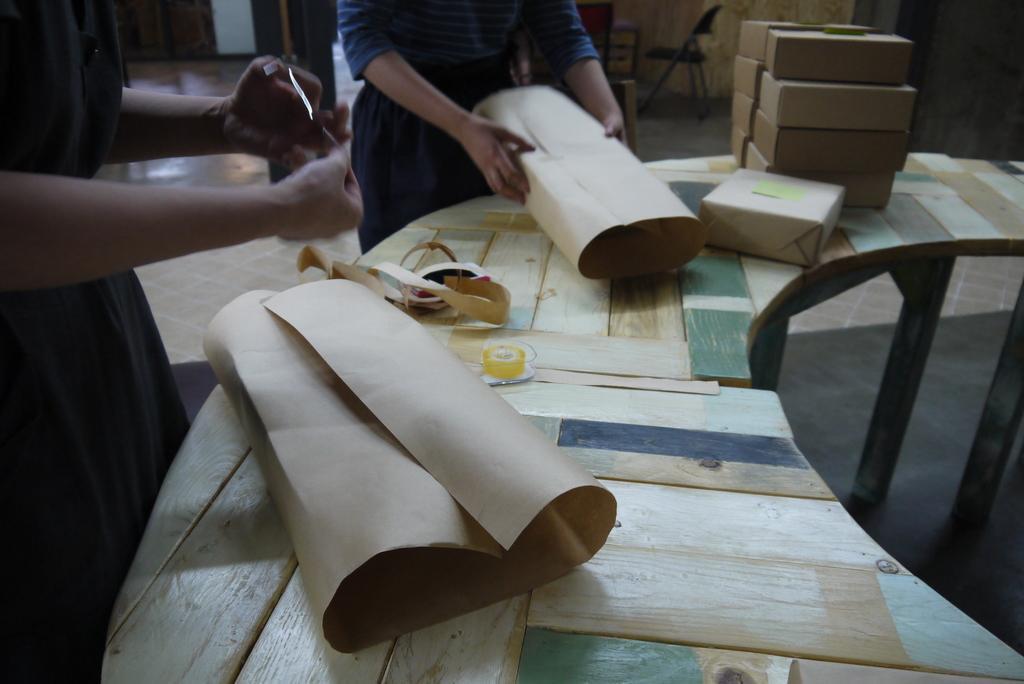Please provide a concise description of this image. There are some packing boxes on a table. Two women are packing the boxes with a brown sheet. A woman is packing the box and the other is pasting it with a plaster. 